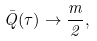Convert formula to latex. <formula><loc_0><loc_0><loc_500><loc_500>\bar { Q } ( \tau ) \to \frac { m } { 2 } ,</formula> 